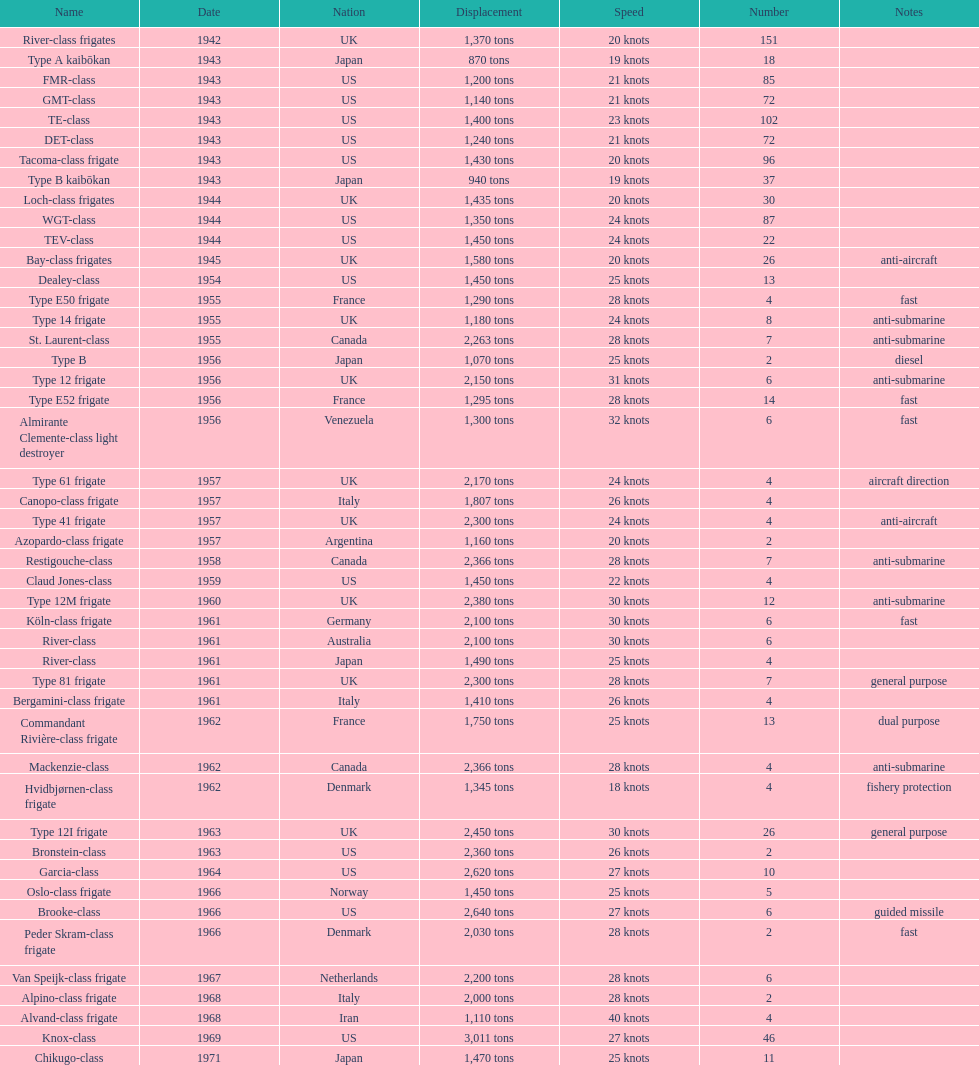How many consecutive escorts were in 1943? 7. 